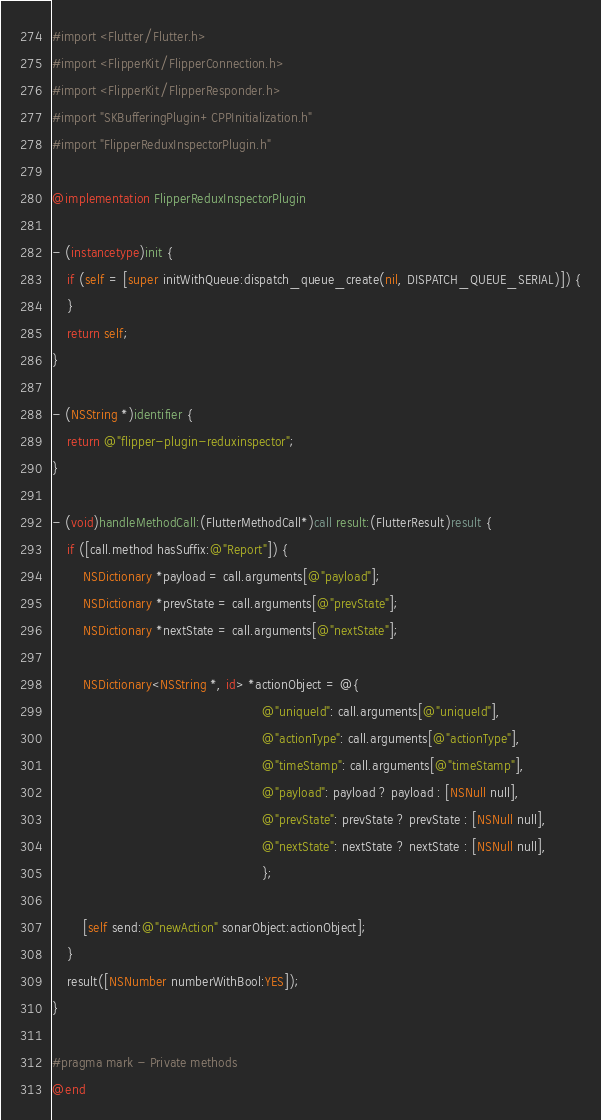<code> <loc_0><loc_0><loc_500><loc_500><_ObjectiveC_>#import <Flutter/Flutter.h>
#import <FlipperKit/FlipperConnection.h>
#import <FlipperKit/FlipperResponder.h>
#import "SKBufferingPlugin+CPPInitialization.h"
#import "FlipperReduxInspectorPlugin.h"

@implementation FlipperReduxInspectorPlugin

- (instancetype)init {
    if (self = [super initWithQueue:dispatch_queue_create(nil, DISPATCH_QUEUE_SERIAL)]) {
    }
    return self;
}

- (NSString *)identifier {
    return @"flipper-plugin-reduxinspector";
}

- (void)handleMethodCall:(FlutterMethodCall*)call result:(FlutterResult)result {
    if ([call.method hasSuffix:@"Report"]) {
        NSDictionary *payload = call.arguments[@"payload"];
        NSDictionary *prevState = call.arguments[@"prevState"];
        NSDictionary *nextState = call.arguments[@"nextState"];

        NSDictionary<NSString *, id> *actionObject = @{
                                                       @"uniqueId": call.arguments[@"uniqueId"],
                                                       @"actionType": call.arguments[@"actionType"],
                                                       @"timeStamp": call.arguments[@"timeStamp"],
                                                       @"payload": payload ? payload : [NSNull null],
                                                       @"prevState": prevState ? prevState : [NSNull null],
                                                       @"nextState": nextState ? nextState : [NSNull null],
                                                       };

        [self send:@"newAction" sonarObject:actionObject];
    }
    result([NSNumber numberWithBool:YES]);
}

#pragma mark - Private methods
@end
</code> 